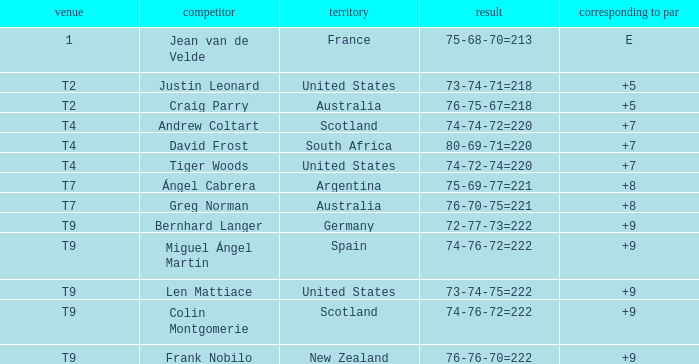Could you help me parse every detail presented in this table? {'header': ['venue', 'competitor', 'territory', 'result', 'corresponding to par'], 'rows': [['1', 'Jean van de Velde', 'France', '75-68-70=213', 'E'], ['T2', 'Justin Leonard', 'United States', '73-74-71=218', '+5'], ['T2', 'Craig Parry', 'Australia', '76-75-67=218', '+5'], ['T4', 'Andrew Coltart', 'Scotland', '74-74-72=220', '+7'], ['T4', 'David Frost', 'South Africa', '80-69-71=220', '+7'], ['T4', 'Tiger Woods', 'United States', '74-72-74=220', '+7'], ['T7', 'Ángel Cabrera', 'Argentina', '75-69-77=221', '+8'], ['T7', 'Greg Norman', 'Australia', '76-70-75=221', '+8'], ['T9', 'Bernhard Langer', 'Germany', '72-77-73=222', '+9'], ['T9', 'Miguel Ángel Martín', 'Spain', '74-76-72=222', '+9'], ['T9', 'Len Mattiace', 'United States', '73-74-75=222', '+9'], ['T9', 'Colin Montgomerie', 'Scotland', '74-76-72=222', '+9'], ['T9', 'Frank Nobilo', 'New Zealand', '76-76-70=222', '+9']]} Player Craig Parry of Australia is in what place number? T2. 